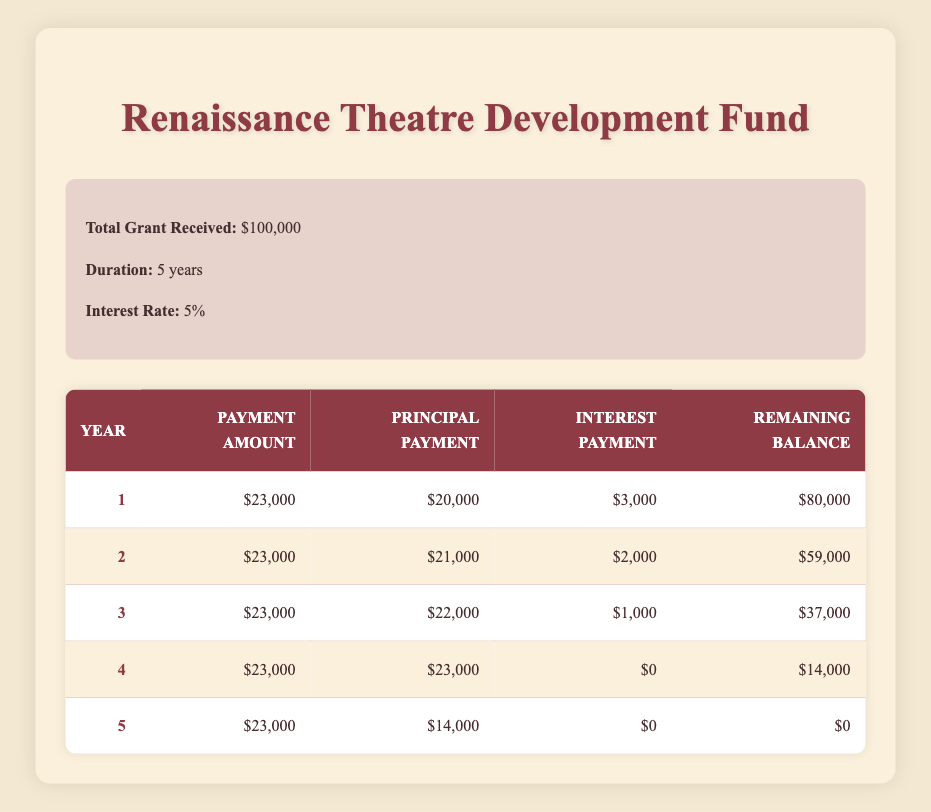What is the total grant received for the Renaissance Theatre Development Fund? The total grant received is listed at the start of the table, showing $100,000.
Answer: $100,000 How much was paid in the third year? The payment amount for the third year is explicitly shown as $23,000 in the table for payment year 3.
Answer: $23,000 What was the principal payment for the first year? The principal payment for the first year is specifically stated in the table, which shows $20,000 for payment year 1.
Answer: $20,000 Is the interest payment for the fourth year zero? The table indicates an interest payment of $0 in payment year 4, confirming that it is indeed zero.
Answer: Yes What is the total principal payment across all five years? By adding the principal payments from all years, we get $20,000 + $21,000 + $22,000 + $23,000 + $14,000 = $100,000. This shows the total principal payment equals the total grant received.
Answer: $100,000 What is the average remaining balance at the end of each year? The remaining balances are $80,000 (year 1), $59,000 (year 2), $37,000 (year 3), $14,000 (year 4), and $0 (year 5). The sum is $80,000 + $59,000 + $37,000 + $14,000 + $0 = $190,000. Dividing by 5 results in an average of $38,000.
Answer: $38,000 How much does the remaining balance decrease from year 3 to year 4? The remaining balance for year 3 is $37,000 and for year 4 is $14,000. The decrease is calculated as $37,000 - $14,000 = $23,000.
Answer: $23,000 Did the program make an interest payment in the last year? The table shows an interest payment of $0 in payment year 5, indicating no interest payment was made in the final year.
Answer: No What was the principal payment for the second year compared to the first year? The principal payment for the second year is $21,000, whereas for the first year it is $20,000, showing that the second year payment was $1,000 higher.
Answer: $1,000 higher 